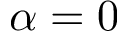Convert formula to latex. <formula><loc_0><loc_0><loc_500><loc_500>\alpha = 0</formula> 